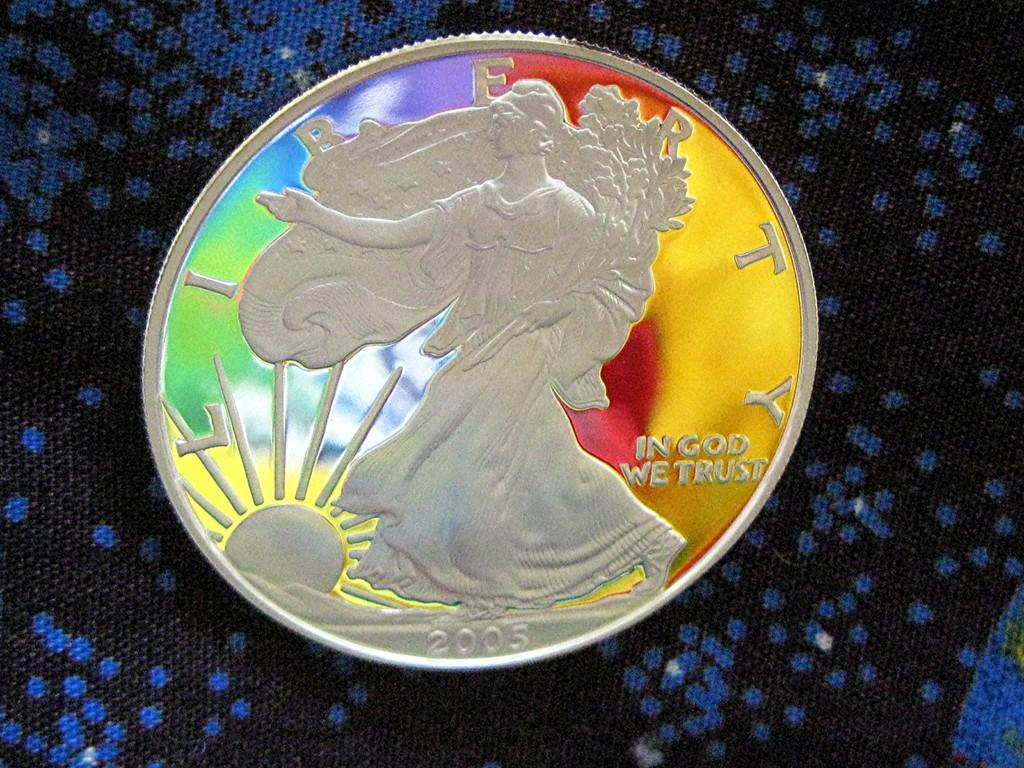<image>
Describe the image concisely. A rainbow colored coin from 2005 sits on a blue and black surface. 